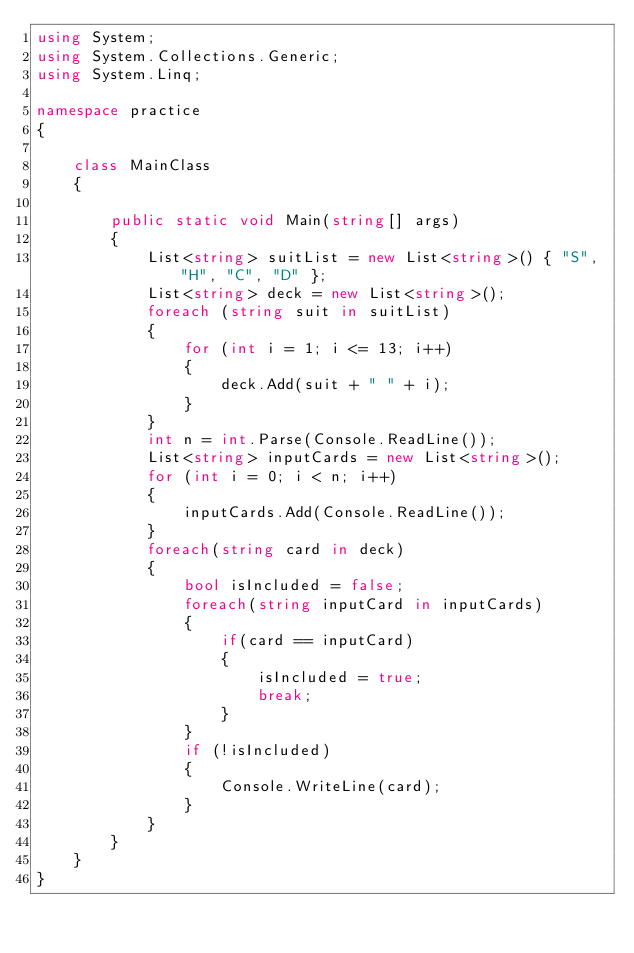<code> <loc_0><loc_0><loc_500><loc_500><_C#_>using System;
using System.Collections.Generic;
using System.Linq;

namespace practice
{ 

    class MainClass
    {

        public static void Main(string[] args)
        {
            List<string> suitList = new List<string>() { "S", "H", "C", "D" };
            List<string> deck = new List<string>();
            foreach (string suit in suitList)
            {
                for (int i = 1; i <= 13; i++)
                {
                    deck.Add(suit + " " + i);
                }
            }
            int n = int.Parse(Console.ReadLine());
            List<string> inputCards = new List<string>();
            for (int i = 0; i < n; i++)
            {
                inputCards.Add(Console.ReadLine());
            }
            foreach(string card in deck)
            {
                bool isIncluded = false;
                foreach(string inputCard in inputCards)
                {
                    if(card == inputCard)
                    {
                        isIncluded = true;
                        break;
                    }
                }
                if (!isIncluded)
                {
                    Console.WriteLine(card);
                }
            }
        }
    }
}
</code> 